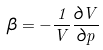<formula> <loc_0><loc_0><loc_500><loc_500>\beta = - { \frac { 1 } { V } } { \frac { \partial V } { \partial p } }</formula> 